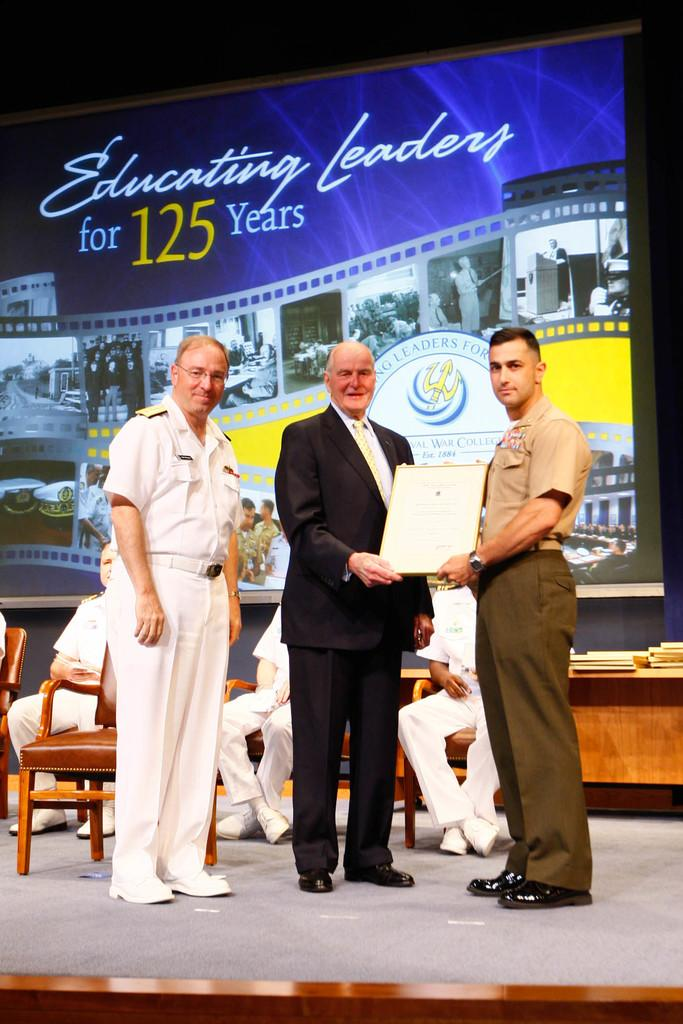What is hanging or displayed in the image? There is a banner in the image. What are the people in the image doing? The people in the image are sitting on chairs. How many people are standing in the image? There are three people standing in the image. Can you see a quill being used to write a verse on the banner in the image? There is no quill or verse present on the banner in the image. 